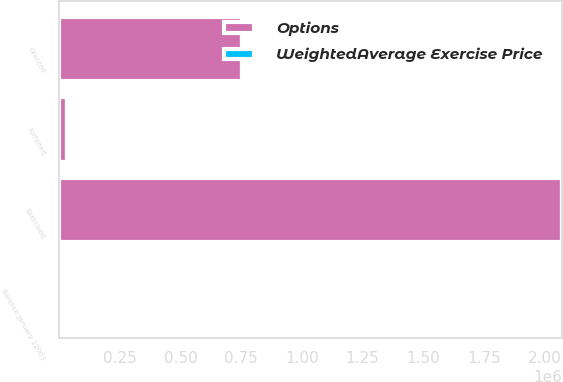Convert chart. <chart><loc_0><loc_0><loc_500><loc_500><stacked_bar_chart><ecel><fcel>Balance January 12003<fcel>Granted<fcel>Exercised<fcel>Forfeited<nl><fcel>Options<fcel>18.35<fcel>754850<fcel>2.07103e+06<fcel>31375<nl><fcel>WeightedAverage Exercise Price<fcel>9.1<fcel>18.35<fcel>5.62<fcel>16.42<nl></chart> 